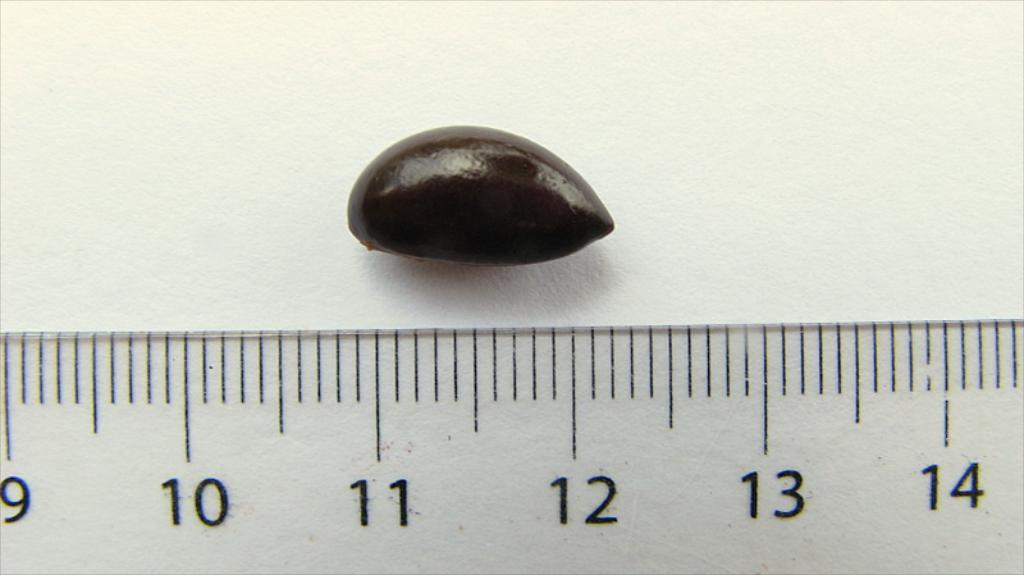<image>
Summarize the visual content of the image. A stone or nut being measured against a ruler at the 11 and 12 mark. 